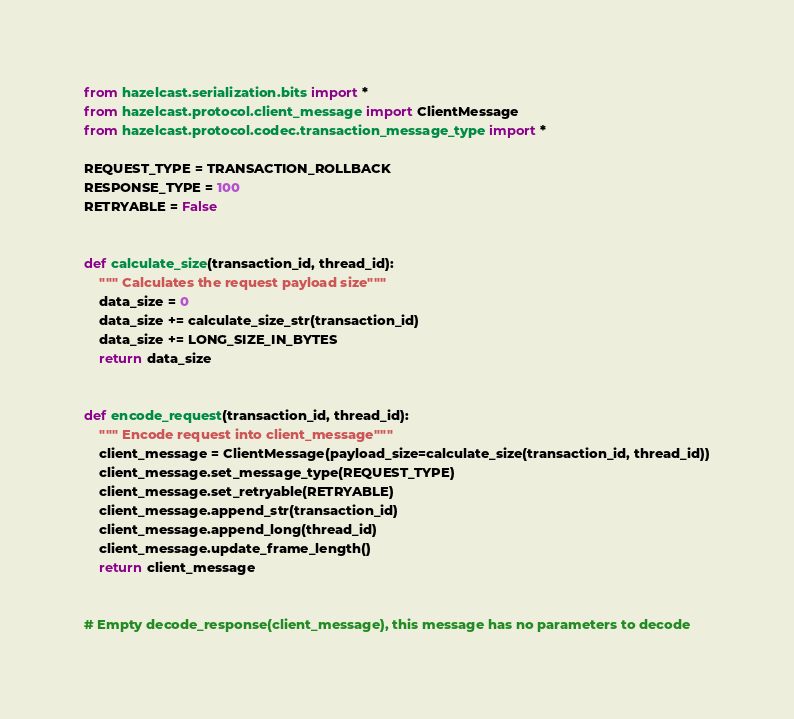<code> <loc_0><loc_0><loc_500><loc_500><_Python_>from hazelcast.serialization.bits import *
from hazelcast.protocol.client_message import ClientMessage
from hazelcast.protocol.codec.transaction_message_type import *

REQUEST_TYPE = TRANSACTION_ROLLBACK
RESPONSE_TYPE = 100
RETRYABLE = False


def calculate_size(transaction_id, thread_id):
    """ Calculates the request payload size"""
    data_size = 0
    data_size += calculate_size_str(transaction_id)
    data_size += LONG_SIZE_IN_BYTES
    return data_size


def encode_request(transaction_id, thread_id):
    """ Encode request into client_message"""
    client_message = ClientMessage(payload_size=calculate_size(transaction_id, thread_id))
    client_message.set_message_type(REQUEST_TYPE)
    client_message.set_retryable(RETRYABLE)
    client_message.append_str(transaction_id)
    client_message.append_long(thread_id)
    client_message.update_frame_length()
    return client_message


# Empty decode_response(client_message), this message has no parameters to decode
</code> 